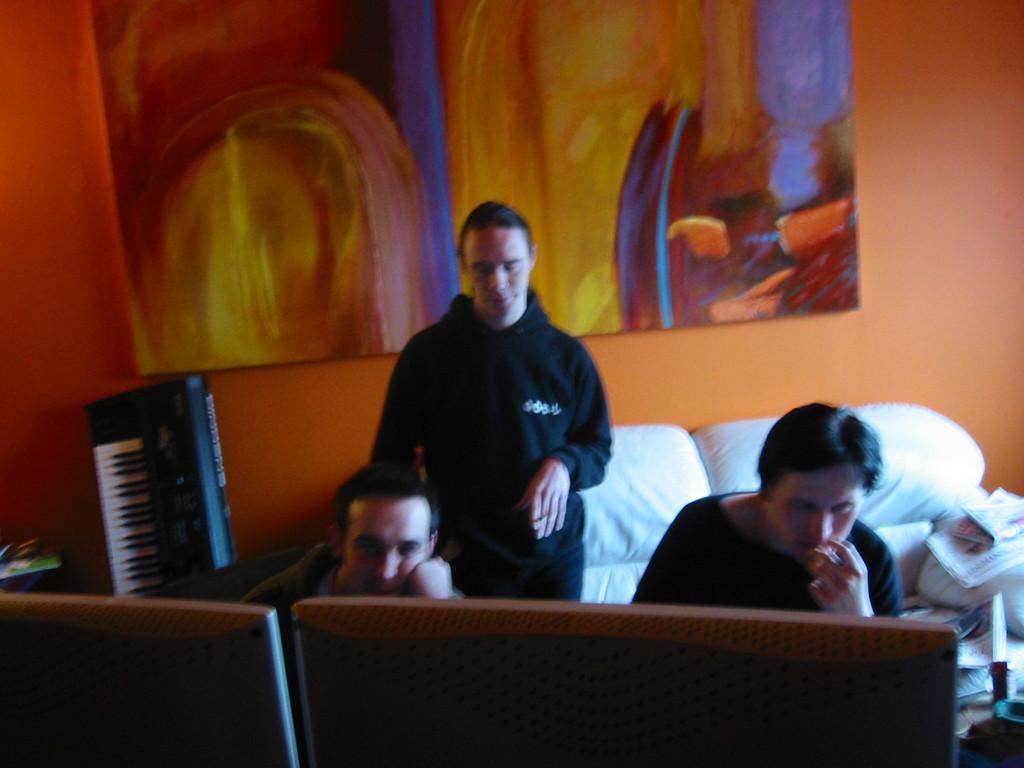Can you describe this image briefly? In this image, on the right side and on the middle, we can see two people are in front of two monitors. In the middle of the image, we can also see a black color dress man is standing. On the left side, we can also see a musical keyboard and some object. On the right side, we can also see some object. In the background, we can see a couch, on the couch, we can see some books. In the background, we can also see a painting which is attached to a wall which is in orange color. 